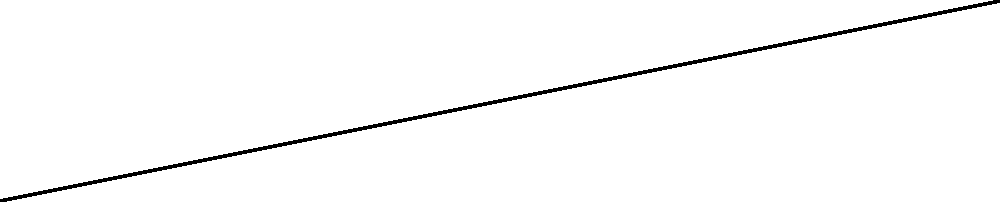A yoga mat is being rolled up, forming a spiral path that can be represented in polar coordinates by the equation $r = 0.2\theta$, where $r$ is in meters and $\theta$ is in radians. If the mat is rolled up for two complete revolutions, what is the total distance traveled by the outer edge of the mat? To solve this problem, we'll follow these steps:

1) First, we need to understand that two complete revolutions means $\theta$ goes from 0 to $4\pi$ radians.

2) The length of a curve in polar coordinates is given by the formula:

   $$L = \int_a^b \sqrt{r^2 + (\frac{dr}{d\theta})^2} d\theta$$

3) For our equation $r = 0.2\theta$, we need to find $\frac{dr}{d\theta}$:
   
   $$\frac{dr}{d\theta} = 0.2$$

4) Now we can substitute these into our length formula:

   $$L = \int_0^{4\pi} \sqrt{(0.2\theta)^2 + (0.2)^2} d\theta$$

5) Simplify under the square root:

   $$L = \int_0^{4\pi} \sqrt{0.04\theta^2 + 0.04} d\theta$$
   $$L = 0.2\int_0^{4\pi} \sqrt{\theta^2 + 1} d\theta$$

6) This integral doesn't have an elementary antiderivative, so we need to use numerical integration methods or consult a table of integrals. The result is:

   $$L = 0.2 \cdot \frac{1}{2}[\theta\sqrt{\theta^2+1} + \ln(\theta + \sqrt{\theta^2+1})]_0^{4\pi}$$

7) Evaluating this at the limits:

   $$L = 0.1[(4\pi\sqrt{(4\pi)^2+1} + \ln(4\pi + \sqrt{(4\pi)^2+1})) - (0 + \ln(1))]$$

8) Simplifying and calculating:

   $$L \approx 5.13\text{ meters}$$
Answer: $5.13\text{ m}$ 